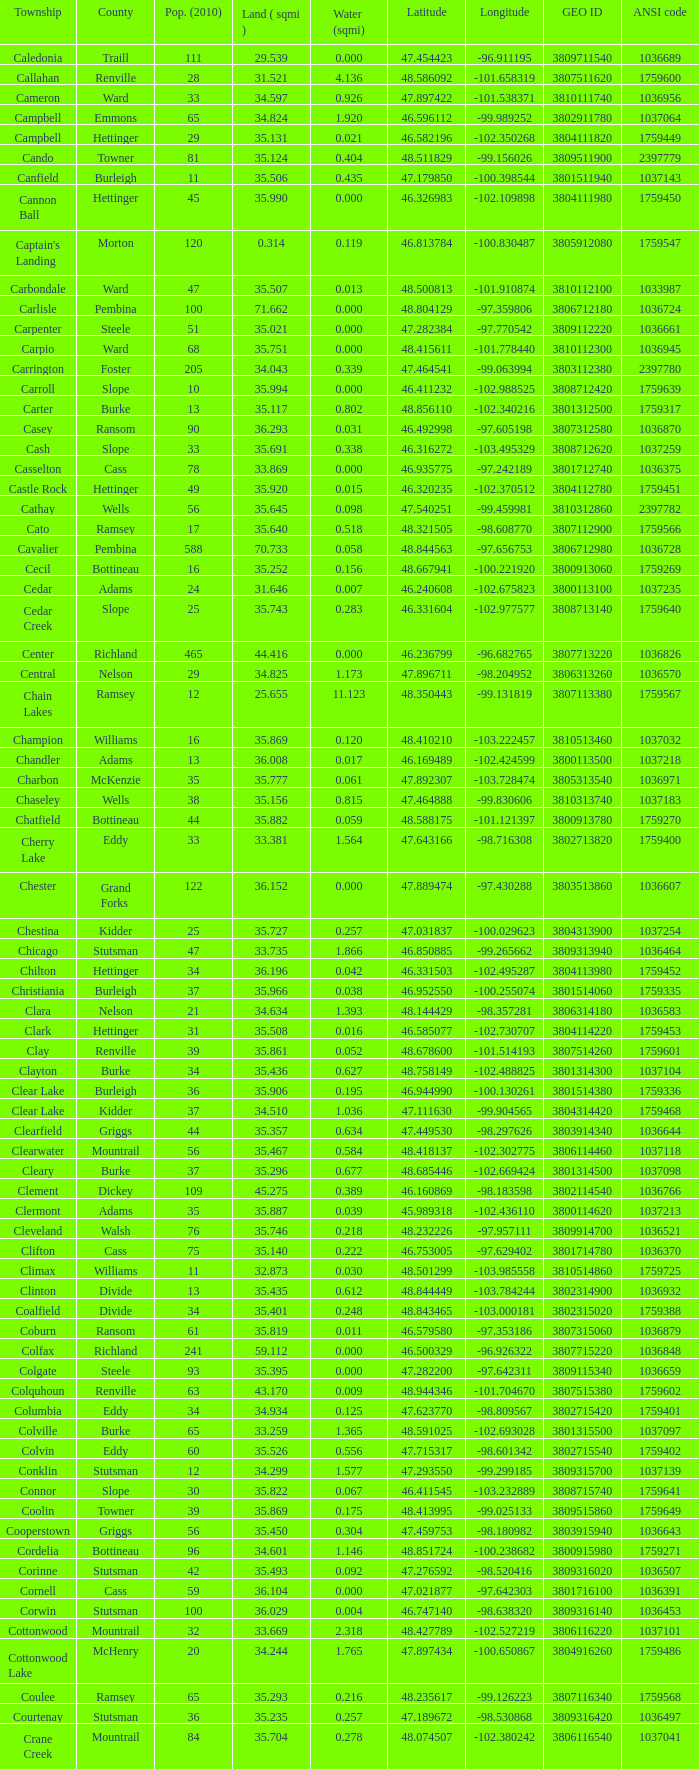Could you help me parse every detail presented in this table? {'header': ['Township', 'County', 'Pop. (2010)', 'Land ( sqmi )', 'Water (sqmi)', 'Latitude', 'Longitude', 'GEO ID', 'ANSI code'], 'rows': [['Caledonia', 'Traill', '111', '29.539', '0.000', '47.454423', '-96.911195', '3809711540', '1036689'], ['Callahan', 'Renville', '28', '31.521', '4.136', '48.586092', '-101.658319', '3807511620', '1759600'], ['Cameron', 'Ward', '33', '34.597', '0.926', '47.897422', '-101.538371', '3810111740', '1036956'], ['Campbell', 'Emmons', '65', '34.824', '1.920', '46.596112', '-99.989252', '3802911780', '1037064'], ['Campbell', 'Hettinger', '29', '35.131', '0.021', '46.582196', '-102.350268', '3804111820', '1759449'], ['Cando', 'Towner', '81', '35.124', '0.404', '48.511829', '-99.156026', '3809511900', '2397779'], ['Canfield', 'Burleigh', '11', '35.506', '0.435', '47.179850', '-100.398544', '3801511940', '1037143'], ['Cannon Ball', 'Hettinger', '45', '35.990', '0.000', '46.326983', '-102.109898', '3804111980', '1759450'], ["Captain's Landing", 'Morton', '120', '0.314', '0.119', '46.813784', '-100.830487', '3805912080', '1759547'], ['Carbondale', 'Ward', '47', '35.507', '0.013', '48.500813', '-101.910874', '3810112100', '1033987'], ['Carlisle', 'Pembina', '100', '71.662', '0.000', '48.804129', '-97.359806', '3806712180', '1036724'], ['Carpenter', 'Steele', '51', '35.021', '0.000', '47.282384', '-97.770542', '3809112220', '1036661'], ['Carpio', 'Ward', '68', '35.751', '0.000', '48.415611', '-101.778440', '3810112300', '1036945'], ['Carrington', 'Foster', '205', '34.043', '0.339', '47.464541', '-99.063994', '3803112380', '2397780'], ['Carroll', 'Slope', '10', '35.994', '0.000', '46.411232', '-102.988525', '3808712420', '1759639'], ['Carter', 'Burke', '13', '35.117', '0.802', '48.856110', '-102.340216', '3801312500', '1759317'], ['Casey', 'Ransom', '90', '36.293', '0.031', '46.492998', '-97.605198', '3807312580', '1036870'], ['Cash', 'Slope', '33', '35.691', '0.338', '46.316272', '-103.495329', '3808712620', '1037259'], ['Casselton', 'Cass', '78', '33.869', '0.000', '46.935775', '-97.242189', '3801712740', '1036375'], ['Castle Rock', 'Hettinger', '49', '35.920', '0.015', '46.320235', '-102.370512', '3804112780', '1759451'], ['Cathay', 'Wells', '56', '35.645', '0.098', '47.540251', '-99.459981', '3810312860', '2397782'], ['Cato', 'Ramsey', '17', '35.640', '0.518', '48.321505', '-98.608770', '3807112900', '1759566'], ['Cavalier', 'Pembina', '588', '70.733', '0.058', '48.844563', '-97.656753', '3806712980', '1036728'], ['Cecil', 'Bottineau', '16', '35.252', '0.156', '48.667941', '-100.221920', '3800913060', '1759269'], ['Cedar', 'Adams', '24', '31.646', '0.007', '46.240608', '-102.675823', '3800113100', '1037235'], ['Cedar Creek', 'Slope', '25', '35.743', '0.283', '46.331604', '-102.977577', '3808713140', '1759640'], ['Center', 'Richland', '465', '44.416', '0.000', '46.236799', '-96.682765', '3807713220', '1036826'], ['Central', 'Nelson', '29', '34.825', '1.173', '47.896711', '-98.204952', '3806313260', '1036570'], ['Chain Lakes', 'Ramsey', '12', '25.655', '11.123', '48.350443', '-99.131819', '3807113380', '1759567'], ['Champion', 'Williams', '16', '35.869', '0.120', '48.410210', '-103.222457', '3810513460', '1037032'], ['Chandler', 'Adams', '13', '36.008', '0.017', '46.169489', '-102.424599', '3800113500', '1037218'], ['Charbon', 'McKenzie', '35', '35.777', '0.061', '47.892307', '-103.728474', '3805313540', '1036971'], ['Chaseley', 'Wells', '38', '35.156', '0.815', '47.464888', '-99.830606', '3810313740', '1037183'], ['Chatfield', 'Bottineau', '44', '35.882', '0.059', '48.588175', '-101.121397', '3800913780', '1759270'], ['Cherry Lake', 'Eddy', '33', '33.381', '1.564', '47.643166', '-98.716308', '3802713820', '1759400'], ['Chester', 'Grand Forks', '122', '36.152', '0.000', '47.889474', '-97.430288', '3803513860', '1036607'], ['Chestina', 'Kidder', '25', '35.727', '0.257', '47.031837', '-100.029623', '3804313900', '1037254'], ['Chicago', 'Stutsman', '47', '33.735', '1.866', '46.850885', '-99.265662', '3809313940', '1036464'], ['Chilton', 'Hettinger', '34', '36.196', '0.042', '46.331503', '-102.495287', '3804113980', '1759452'], ['Christiania', 'Burleigh', '37', '35.966', '0.038', '46.952550', '-100.255074', '3801514060', '1759335'], ['Clara', 'Nelson', '21', '34.634', '1.393', '48.144429', '-98.357281', '3806314180', '1036583'], ['Clark', 'Hettinger', '31', '35.508', '0.016', '46.585077', '-102.730707', '3804114220', '1759453'], ['Clay', 'Renville', '39', '35.861', '0.052', '48.678600', '-101.514193', '3807514260', '1759601'], ['Clayton', 'Burke', '34', '35.436', '0.627', '48.758149', '-102.488825', '3801314300', '1037104'], ['Clear Lake', 'Burleigh', '36', '35.906', '0.195', '46.944990', '-100.130261', '3801514380', '1759336'], ['Clear Lake', 'Kidder', '37', '34.510', '1.036', '47.111630', '-99.904565', '3804314420', '1759468'], ['Clearfield', 'Griggs', '44', '35.357', '0.634', '47.449530', '-98.297626', '3803914340', '1036644'], ['Clearwater', 'Mountrail', '56', '35.467', '0.584', '48.418137', '-102.302775', '3806114460', '1037118'], ['Cleary', 'Burke', '37', '35.296', '0.677', '48.685446', '-102.669424', '3801314500', '1037098'], ['Clement', 'Dickey', '109', '45.275', '0.389', '46.160869', '-98.183598', '3802114540', '1036766'], ['Clermont', 'Adams', '35', '35.887', '0.039', '45.989318', '-102.436110', '3800114620', '1037213'], ['Cleveland', 'Walsh', '76', '35.746', '0.218', '48.232226', '-97.957111', '3809914700', '1036521'], ['Clifton', 'Cass', '75', '35.140', '0.222', '46.753005', '-97.629402', '3801714780', '1036370'], ['Climax', 'Williams', '11', '32.873', '0.030', '48.501299', '-103.985558', '3810514860', '1759725'], ['Clinton', 'Divide', '13', '35.435', '0.612', '48.844449', '-103.784244', '3802314900', '1036932'], ['Coalfield', 'Divide', '34', '35.401', '0.248', '48.843465', '-103.000181', '3802315020', '1759388'], ['Coburn', 'Ransom', '61', '35.819', '0.011', '46.579580', '-97.353186', '3807315060', '1036879'], ['Colfax', 'Richland', '241', '59.112', '0.000', '46.500329', '-96.926322', '3807715220', '1036848'], ['Colgate', 'Steele', '93', '35.395', '0.000', '47.282200', '-97.642311', '3809115340', '1036659'], ['Colquhoun', 'Renville', '63', '43.170', '0.009', '48.944346', '-101.704670', '3807515380', '1759602'], ['Columbia', 'Eddy', '34', '34.934', '0.125', '47.623770', '-98.809567', '3802715420', '1759401'], ['Colville', 'Burke', '65', '33.259', '1.365', '48.591025', '-102.693028', '3801315500', '1037097'], ['Colvin', 'Eddy', '60', '35.526', '0.556', '47.715317', '-98.601342', '3802715540', '1759402'], ['Conklin', 'Stutsman', '12', '34.299', '1.577', '47.293550', '-99.299185', '3809315700', '1037139'], ['Connor', 'Slope', '30', '35.822', '0.067', '46.411545', '-103.232889', '3808715740', '1759641'], ['Coolin', 'Towner', '39', '35.869', '0.175', '48.413995', '-99.025133', '3809515860', '1759649'], ['Cooperstown', 'Griggs', '56', '35.450', '0.304', '47.459753', '-98.180982', '3803915940', '1036643'], ['Cordelia', 'Bottineau', '96', '34.601', '1.146', '48.851724', '-100.238682', '3800915980', '1759271'], ['Corinne', 'Stutsman', '42', '35.493', '0.092', '47.276592', '-98.520416', '3809316020', '1036507'], ['Cornell', 'Cass', '59', '36.104', '0.000', '47.021877', '-97.642303', '3801716100', '1036391'], ['Corwin', 'Stutsman', '100', '36.029', '0.004', '46.747140', '-98.638320', '3809316140', '1036453'], ['Cottonwood', 'Mountrail', '32', '33.669', '2.318', '48.427789', '-102.527219', '3806116220', '1037101'], ['Cottonwood Lake', 'McHenry', '20', '34.244', '1.765', '47.897434', '-100.650867', '3804916260', '1759486'], ['Coulee', 'Ramsey', '65', '35.293', '0.216', '48.235617', '-99.126223', '3807116340', '1759568'], ['Courtenay', 'Stutsman', '36', '35.235', '0.257', '47.189672', '-98.530868', '3809316420', '1036497'], ['Crane Creek', 'Mountrail', '84', '35.704', '0.278', '48.074507', '-102.380242', '3806116540', '1037041'], ['Crawford', 'Slope', '31', '35.892', '0.051', '46.320329', '-103.729934', '3808716620', '1037166'], ['Creel', 'Ramsey', '1305', '14.578', '15.621', '48.075823', '-98.857272', '3807116660', '1759569'], ['Cremerville', 'McLean', '27', '35.739', '0.054', '47.811011', '-102.054883', '3805516700', '1759530'], ['Crocus', 'Towner', '44', '35.047', '0.940', '48.667289', '-99.155787', '3809516820', '1759650'], ['Crofte', 'Burleigh', '199', '36.163', '0.000', '47.026425', '-100.685988', '3801516860', '1037131'], ['Cromwell', 'Burleigh', '35', '36.208', '0.000', '47.026008', '-100.558805', '3801516900', '1037133'], ['Crowfoot', 'Mountrail', '18', '34.701', '1.283', '48.495946', '-102.180433', '3806116980', '1037050'], ['Crown Hill', 'Kidder', '7', '30.799', '1.468', '46.770977', '-100.025924', '3804317020', '1759469'], ['Crystal', 'Pembina', '50', '35.499', '0.000', '48.586423', '-97.732145', '3806717100', '1036718'], ['Crystal Lake', 'Wells', '32', '35.522', '0.424', '47.541346', '-99.974737', '3810317140', '1037152'], ['Crystal Springs', 'Kidder', '32', '35.415', '0.636', '46.848792', '-99.529639', '3804317220', '1759470'], ['Cuba', 'Barnes', '76', '35.709', '0.032', '46.851144', '-97.860271', '3800317300', '1036409'], ['Cusator', 'Stutsman', '26', '34.878', '0.693', '46.746853', '-98.997611', '3809317460', '1036459'], ['Cut Bank', 'Bottineau', '37', '35.898', '0.033', '48.763937', '-101.430571', '3800917540', '1759272']]} What was the county with a latitude of 46.770977? Kidder. 